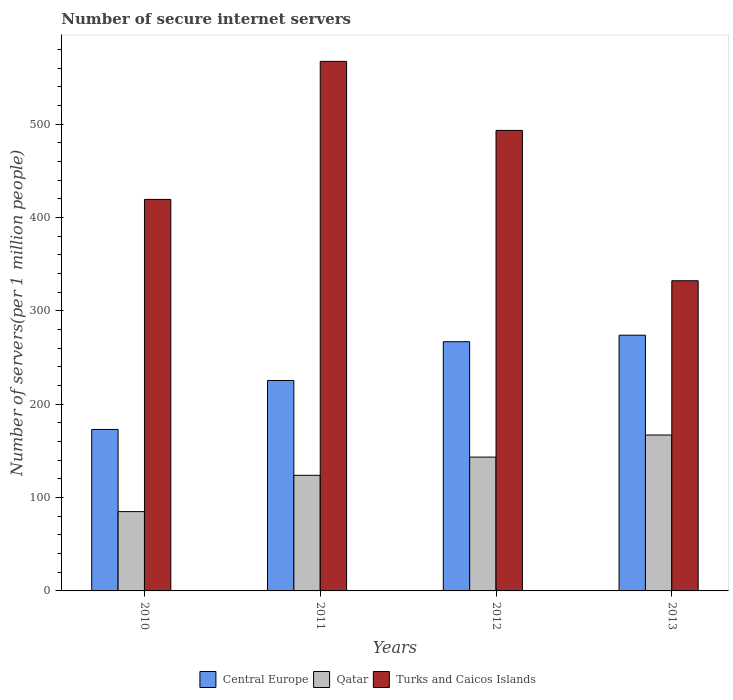How many different coloured bars are there?
Provide a succinct answer. 3. How many groups of bars are there?
Keep it short and to the point. 4. Are the number of bars per tick equal to the number of legend labels?
Offer a very short reply. Yes. How many bars are there on the 1st tick from the left?
Ensure brevity in your answer.  3. How many bars are there on the 4th tick from the right?
Offer a terse response. 3. What is the label of the 4th group of bars from the left?
Provide a succinct answer. 2013. In how many cases, is the number of bars for a given year not equal to the number of legend labels?
Your answer should be compact. 0. What is the number of secure internet servers in Qatar in 2012?
Your answer should be compact. 143.38. Across all years, what is the maximum number of secure internet servers in Central Europe?
Ensure brevity in your answer.  273.97. Across all years, what is the minimum number of secure internet servers in Central Europe?
Provide a succinct answer. 172.97. In which year was the number of secure internet servers in Turks and Caicos Islands maximum?
Offer a terse response. 2011. In which year was the number of secure internet servers in Turks and Caicos Islands minimum?
Make the answer very short. 2013. What is the total number of secure internet servers in Qatar in the graph?
Give a very brief answer. 519.24. What is the difference between the number of secure internet servers in Central Europe in 2010 and that in 2013?
Offer a terse response. -101. What is the difference between the number of secure internet servers in Turks and Caicos Islands in 2011 and the number of secure internet servers in Central Europe in 2013?
Give a very brief answer. 293.37. What is the average number of secure internet servers in Turks and Caicos Islands per year?
Provide a succinct answer. 453.11. In the year 2010, what is the difference between the number of secure internet servers in Turks and Caicos Islands and number of secure internet servers in Central Europe?
Make the answer very short. 246.48. In how many years, is the number of secure internet servers in Central Europe greater than 60?
Offer a very short reply. 4. What is the ratio of the number of secure internet servers in Turks and Caicos Islands in 2012 to that in 2013?
Offer a very short reply. 1.48. Is the number of secure internet servers in Central Europe in 2011 less than that in 2013?
Make the answer very short. Yes. What is the difference between the highest and the second highest number of secure internet servers in Central Europe?
Provide a short and direct response. 6.98. What is the difference between the highest and the lowest number of secure internet servers in Central Europe?
Your response must be concise. 101. In how many years, is the number of secure internet servers in Turks and Caicos Islands greater than the average number of secure internet servers in Turks and Caicos Islands taken over all years?
Your answer should be very brief. 2. What does the 1st bar from the left in 2011 represents?
Ensure brevity in your answer.  Central Europe. What does the 3rd bar from the right in 2013 represents?
Your answer should be compact. Central Europe. What is the difference between two consecutive major ticks on the Y-axis?
Offer a very short reply. 100. Are the values on the major ticks of Y-axis written in scientific E-notation?
Make the answer very short. No. Does the graph contain any zero values?
Your answer should be compact. No. Does the graph contain grids?
Offer a very short reply. No. What is the title of the graph?
Your answer should be very brief. Number of secure internet servers. What is the label or title of the Y-axis?
Offer a very short reply. Number of servers(per 1 million people). What is the Number of servers(per 1 million people) of Central Europe in 2010?
Offer a very short reply. 172.97. What is the Number of servers(per 1 million people) in Qatar in 2010?
Your answer should be very brief. 84.96. What is the Number of servers(per 1 million people) of Turks and Caicos Islands in 2010?
Give a very brief answer. 419.45. What is the Number of servers(per 1 million people) of Central Europe in 2011?
Give a very brief answer. 225.45. What is the Number of servers(per 1 million people) in Qatar in 2011?
Your response must be concise. 123.86. What is the Number of servers(per 1 million people) of Turks and Caicos Islands in 2011?
Provide a short and direct response. 567.34. What is the Number of servers(per 1 million people) of Central Europe in 2012?
Ensure brevity in your answer.  266.98. What is the Number of servers(per 1 million people) in Qatar in 2012?
Your answer should be compact. 143.38. What is the Number of servers(per 1 million people) in Turks and Caicos Islands in 2012?
Your answer should be compact. 493.37. What is the Number of servers(per 1 million people) in Central Europe in 2013?
Your response must be concise. 273.97. What is the Number of servers(per 1 million people) in Qatar in 2013?
Offer a terse response. 167.04. What is the Number of servers(per 1 million people) in Turks and Caicos Islands in 2013?
Provide a short and direct response. 332.3. Across all years, what is the maximum Number of servers(per 1 million people) of Central Europe?
Give a very brief answer. 273.97. Across all years, what is the maximum Number of servers(per 1 million people) of Qatar?
Offer a terse response. 167.04. Across all years, what is the maximum Number of servers(per 1 million people) of Turks and Caicos Islands?
Your answer should be very brief. 567.34. Across all years, what is the minimum Number of servers(per 1 million people) in Central Europe?
Make the answer very short. 172.97. Across all years, what is the minimum Number of servers(per 1 million people) of Qatar?
Offer a terse response. 84.96. Across all years, what is the minimum Number of servers(per 1 million people) in Turks and Caicos Islands?
Ensure brevity in your answer.  332.3. What is the total Number of servers(per 1 million people) in Central Europe in the graph?
Offer a very short reply. 939.37. What is the total Number of servers(per 1 million people) of Qatar in the graph?
Offer a terse response. 519.24. What is the total Number of servers(per 1 million people) in Turks and Caicos Islands in the graph?
Your response must be concise. 1812.46. What is the difference between the Number of servers(per 1 million people) in Central Europe in 2010 and that in 2011?
Make the answer very short. -52.48. What is the difference between the Number of servers(per 1 million people) in Qatar in 2010 and that in 2011?
Your answer should be compact. -38.9. What is the difference between the Number of servers(per 1 million people) of Turks and Caicos Islands in 2010 and that in 2011?
Your answer should be compact. -147.89. What is the difference between the Number of servers(per 1 million people) in Central Europe in 2010 and that in 2012?
Offer a very short reply. -94.01. What is the difference between the Number of servers(per 1 million people) of Qatar in 2010 and that in 2012?
Make the answer very short. -58.42. What is the difference between the Number of servers(per 1 million people) in Turks and Caicos Islands in 2010 and that in 2012?
Keep it short and to the point. -73.92. What is the difference between the Number of servers(per 1 million people) in Central Europe in 2010 and that in 2013?
Offer a terse response. -101. What is the difference between the Number of servers(per 1 million people) in Qatar in 2010 and that in 2013?
Offer a terse response. -82.08. What is the difference between the Number of servers(per 1 million people) of Turks and Caicos Islands in 2010 and that in 2013?
Your response must be concise. 87.15. What is the difference between the Number of servers(per 1 million people) in Central Europe in 2011 and that in 2012?
Ensure brevity in your answer.  -41.53. What is the difference between the Number of servers(per 1 million people) in Qatar in 2011 and that in 2012?
Provide a succinct answer. -19.52. What is the difference between the Number of servers(per 1 million people) in Turks and Caicos Islands in 2011 and that in 2012?
Give a very brief answer. 73.97. What is the difference between the Number of servers(per 1 million people) of Central Europe in 2011 and that in 2013?
Keep it short and to the point. -48.52. What is the difference between the Number of servers(per 1 million people) of Qatar in 2011 and that in 2013?
Your response must be concise. -43.18. What is the difference between the Number of servers(per 1 million people) of Turks and Caicos Islands in 2011 and that in 2013?
Give a very brief answer. 235.04. What is the difference between the Number of servers(per 1 million people) in Central Europe in 2012 and that in 2013?
Make the answer very short. -6.98. What is the difference between the Number of servers(per 1 million people) in Qatar in 2012 and that in 2013?
Your response must be concise. -23.66. What is the difference between the Number of servers(per 1 million people) of Turks and Caicos Islands in 2012 and that in 2013?
Ensure brevity in your answer.  161.07. What is the difference between the Number of servers(per 1 million people) in Central Europe in 2010 and the Number of servers(per 1 million people) in Qatar in 2011?
Provide a succinct answer. 49.11. What is the difference between the Number of servers(per 1 million people) of Central Europe in 2010 and the Number of servers(per 1 million people) of Turks and Caicos Islands in 2011?
Provide a short and direct response. -394.37. What is the difference between the Number of servers(per 1 million people) in Qatar in 2010 and the Number of servers(per 1 million people) in Turks and Caicos Islands in 2011?
Give a very brief answer. -482.38. What is the difference between the Number of servers(per 1 million people) in Central Europe in 2010 and the Number of servers(per 1 million people) in Qatar in 2012?
Keep it short and to the point. 29.59. What is the difference between the Number of servers(per 1 million people) of Central Europe in 2010 and the Number of servers(per 1 million people) of Turks and Caicos Islands in 2012?
Ensure brevity in your answer.  -320.4. What is the difference between the Number of servers(per 1 million people) in Qatar in 2010 and the Number of servers(per 1 million people) in Turks and Caicos Islands in 2012?
Your answer should be very brief. -408.41. What is the difference between the Number of servers(per 1 million people) in Central Europe in 2010 and the Number of servers(per 1 million people) in Qatar in 2013?
Give a very brief answer. 5.93. What is the difference between the Number of servers(per 1 million people) in Central Europe in 2010 and the Number of servers(per 1 million people) in Turks and Caicos Islands in 2013?
Make the answer very short. -159.33. What is the difference between the Number of servers(per 1 million people) of Qatar in 2010 and the Number of servers(per 1 million people) of Turks and Caicos Islands in 2013?
Make the answer very short. -247.34. What is the difference between the Number of servers(per 1 million people) in Central Europe in 2011 and the Number of servers(per 1 million people) in Qatar in 2012?
Your answer should be compact. 82.07. What is the difference between the Number of servers(per 1 million people) in Central Europe in 2011 and the Number of servers(per 1 million people) in Turks and Caicos Islands in 2012?
Provide a short and direct response. -267.92. What is the difference between the Number of servers(per 1 million people) in Qatar in 2011 and the Number of servers(per 1 million people) in Turks and Caicos Islands in 2012?
Your answer should be compact. -369.51. What is the difference between the Number of servers(per 1 million people) in Central Europe in 2011 and the Number of servers(per 1 million people) in Qatar in 2013?
Keep it short and to the point. 58.41. What is the difference between the Number of servers(per 1 million people) in Central Europe in 2011 and the Number of servers(per 1 million people) in Turks and Caicos Islands in 2013?
Ensure brevity in your answer.  -106.85. What is the difference between the Number of servers(per 1 million people) in Qatar in 2011 and the Number of servers(per 1 million people) in Turks and Caicos Islands in 2013?
Offer a very short reply. -208.44. What is the difference between the Number of servers(per 1 million people) in Central Europe in 2012 and the Number of servers(per 1 million people) in Qatar in 2013?
Make the answer very short. 99.94. What is the difference between the Number of servers(per 1 million people) in Central Europe in 2012 and the Number of servers(per 1 million people) in Turks and Caicos Islands in 2013?
Your answer should be compact. -65.31. What is the difference between the Number of servers(per 1 million people) of Qatar in 2012 and the Number of servers(per 1 million people) of Turks and Caicos Islands in 2013?
Make the answer very short. -188.92. What is the average Number of servers(per 1 million people) in Central Europe per year?
Offer a very short reply. 234.84. What is the average Number of servers(per 1 million people) of Qatar per year?
Keep it short and to the point. 129.81. What is the average Number of servers(per 1 million people) of Turks and Caicos Islands per year?
Your answer should be very brief. 453.11. In the year 2010, what is the difference between the Number of servers(per 1 million people) in Central Europe and Number of servers(per 1 million people) in Qatar?
Give a very brief answer. 88.01. In the year 2010, what is the difference between the Number of servers(per 1 million people) of Central Europe and Number of servers(per 1 million people) of Turks and Caicos Islands?
Provide a succinct answer. -246.48. In the year 2010, what is the difference between the Number of servers(per 1 million people) of Qatar and Number of servers(per 1 million people) of Turks and Caicos Islands?
Provide a succinct answer. -334.49. In the year 2011, what is the difference between the Number of servers(per 1 million people) in Central Europe and Number of servers(per 1 million people) in Qatar?
Offer a very short reply. 101.59. In the year 2011, what is the difference between the Number of servers(per 1 million people) of Central Europe and Number of servers(per 1 million people) of Turks and Caicos Islands?
Make the answer very short. -341.89. In the year 2011, what is the difference between the Number of servers(per 1 million people) of Qatar and Number of servers(per 1 million people) of Turks and Caicos Islands?
Provide a short and direct response. -443.48. In the year 2012, what is the difference between the Number of servers(per 1 million people) in Central Europe and Number of servers(per 1 million people) in Qatar?
Offer a terse response. 123.6. In the year 2012, what is the difference between the Number of servers(per 1 million people) in Central Europe and Number of servers(per 1 million people) in Turks and Caicos Islands?
Your response must be concise. -226.39. In the year 2012, what is the difference between the Number of servers(per 1 million people) of Qatar and Number of servers(per 1 million people) of Turks and Caicos Islands?
Provide a succinct answer. -349.99. In the year 2013, what is the difference between the Number of servers(per 1 million people) of Central Europe and Number of servers(per 1 million people) of Qatar?
Give a very brief answer. 106.93. In the year 2013, what is the difference between the Number of servers(per 1 million people) of Central Europe and Number of servers(per 1 million people) of Turks and Caicos Islands?
Provide a succinct answer. -58.33. In the year 2013, what is the difference between the Number of servers(per 1 million people) in Qatar and Number of servers(per 1 million people) in Turks and Caicos Islands?
Give a very brief answer. -165.26. What is the ratio of the Number of servers(per 1 million people) in Central Europe in 2010 to that in 2011?
Provide a short and direct response. 0.77. What is the ratio of the Number of servers(per 1 million people) in Qatar in 2010 to that in 2011?
Give a very brief answer. 0.69. What is the ratio of the Number of servers(per 1 million people) in Turks and Caicos Islands in 2010 to that in 2011?
Keep it short and to the point. 0.74. What is the ratio of the Number of servers(per 1 million people) in Central Europe in 2010 to that in 2012?
Keep it short and to the point. 0.65. What is the ratio of the Number of servers(per 1 million people) of Qatar in 2010 to that in 2012?
Offer a terse response. 0.59. What is the ratio of the Number of servers(per 1 million people) of Turks and Caicos Islands in 2010 to that in 2012?
Your answer should be very brief. 0.85. What is the ratio of the Number of servers(per 1 million people) of Central Europe in 2010 to that in 2013?
Offer a terse response. 0.63. What is the ratio of the Number of servers(per 1 million people) of Qatar in 2010 to that in 2013?
Your answer should be very brief. 0.51. What is the ratio of the Number of servers(per 1 million people) in Turks and Caicos Islands in 2010 to that in 2013?
Provide a succinct answer. 1.26. What is the ratio of the Number of servers(per 1 million people) in Central Europe in 2011 to that in 2012?
Your response must be concise. 0.84. What is the ratio of the Number of servers(per 1 million people) of Qatar in 2011 to that in 2012?
Offer a very short reply. 0.86. What is the ratio of the Number of servers(per 1 million people) of Turks and Caicos Islands in 2011 to that in 2012?
Offer a terse response. 1.15. What is the ratio of the Number of servers(per 1 million people) of Central Europe in 2011 to that in 2013?
Provide a short and direct response. 0.82. What is the ratio of the Number of servers(per 1 million people) of Qatar in 2011 to that in 2013?
Ensure brevity in your answer.  0.74. What is the ratio of the Number of servers(per 1 million people) of Turks and Caicos Islands in 2011 to that in 2013?
Keep it short and to the point. 1.71. What is the ratio of the Number of servers(per 1 million people) of Central Europe in 2012 to that in 2013?
Make the answer very short. 0.97. What is the ratio of the Number of servers(per 1 million people) of Qatar in 2012 to that in 2013?
Offer a very short reply. 0.86. What is the ratio of the Number of servers(per 1 million people) in Turks and Caicos Islands in 2012 to that in 2013?
Your answer should be very brief. 1.48. What is the difference between the highest and the second highest Number of servers(per 1 million people) in Central Europe?
Provide a succinct answer. 6.98. What is the difference between the highest and the second highest Number of servers(per 1 million people) in Qatar?
Give a very brief answer. 23.66. What is the difference between the highest and the second highest Number of servers(per 1 million people) of Turks and Caicos Islands?
Keep it short and to the point. 73.97. What is the difference between the highest and the lowest Number of servers(per 1 million people) in Central Europe?
Provide a short and direct response. 101. What is the difference between the highest and the lowest Number of servers(per 1 million people) in Qatar?
Your answer should be compact. 82.08. What is the difference between the highest and the lowest Number of servers(per 1 million people) of Turks and Caicos Islands?
Your answer should be compact. 235.04. 